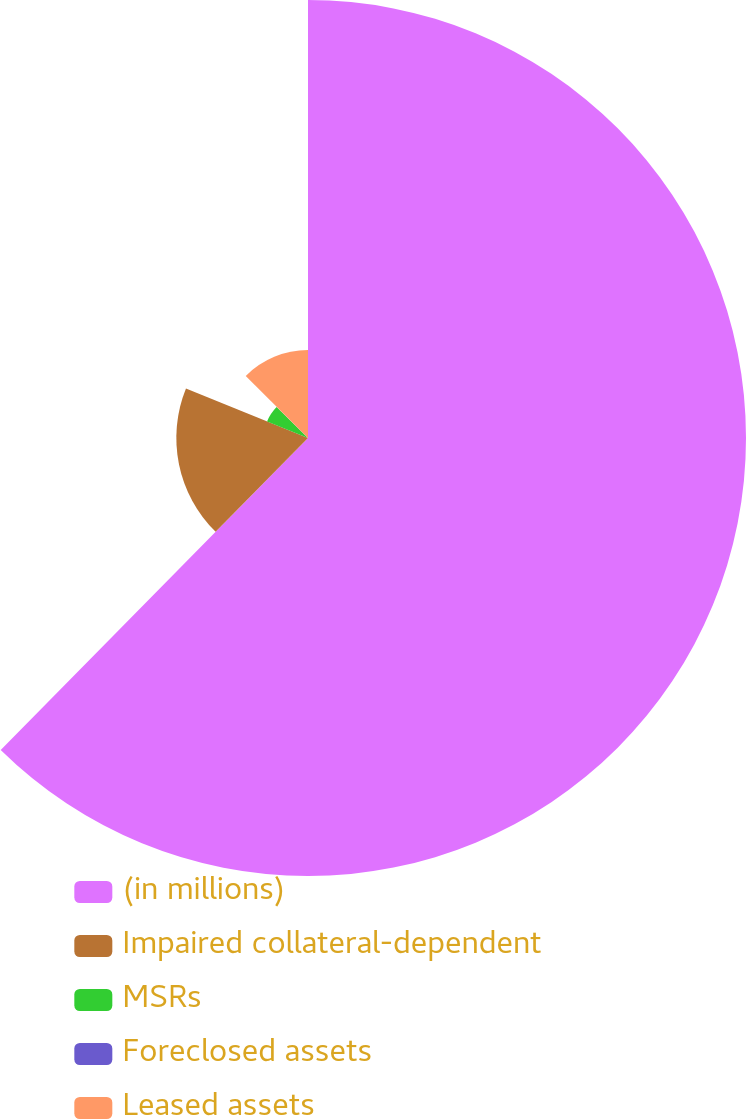Convert chart. <chart><loc_0><loc_0><loc_500><loc_500><pie_chart><fcel>(in millions)<fcel>Impaired collateral-dependent<fcel>MSRs<fcel>Foreclosed assets<fcel>Leased assets<nl><fcel>62.37%<fcel>18.75%<fcel>6.29%<fcel>0.06%<fcel>12.52%<nl></chart> 